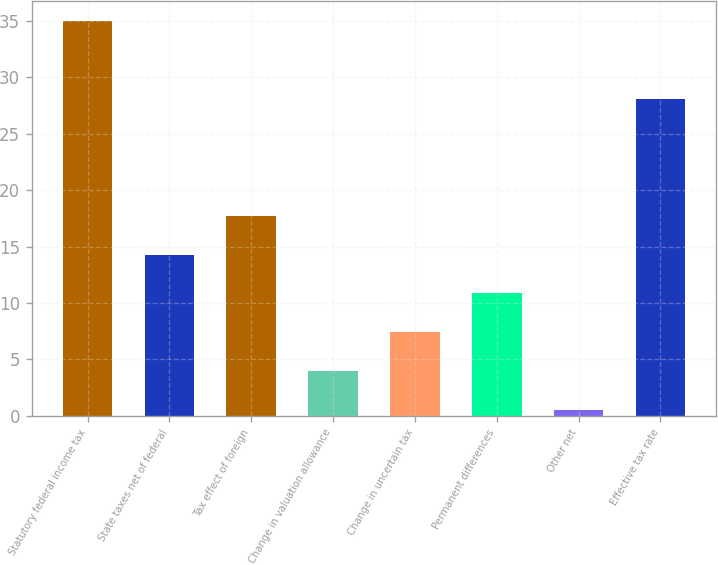<chart> <loc_0><loc_0><loc_500><loc_500><bar_chart><fcel>Statutory federal income tax<fcel>State taxes net of federal<fcel>Tax effect of foreign<fcel>Change in valuation allowance<fcel>Change in uncertain tax<fcel>Permanent differences<fcel>Other net<fcel>Effective tax rate<nl><fcel>35<fcel>14.3<fcel>17.75<fcel>3.95<fcel>7.4<fcel>10.85<fcel>0.5<fcel>28.1<nl></chart> 